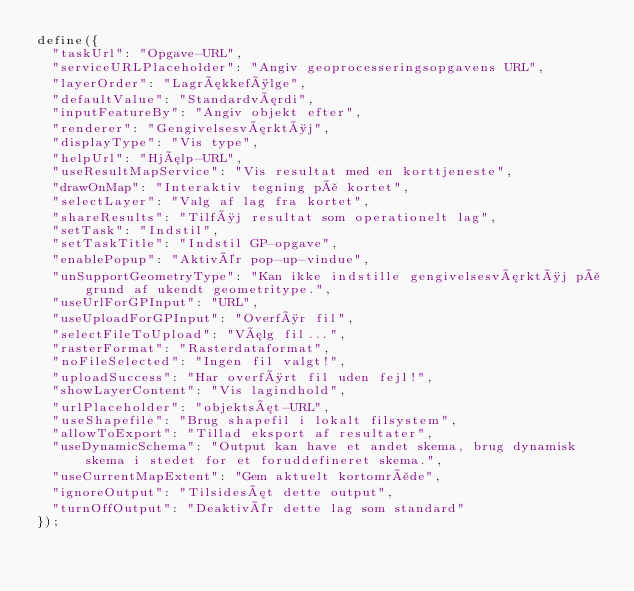<code> <loc_0><loc_0><loc_500><loc_500><_JavaScript_>define({
  "taskUrl": "Opgave-URL",
  "serviceURLPlaceholder": "Angiv geoprocesseringsopgavens URL",
  "layerOrder": "Lagrækkefølge",
  "defaultValue": "Standardværdi",
  "inputFeatureBy": "Angiv objekt efter",
  "renderer": "Gengivelsesværktøj",
  "displayType": "Vis type",
  "helpUrl": "Hjælp-URL",
  "useResultMapService": "Vis resultat med en korttjeneste",
  "drawOnMap": "Interaktiv tegning på kortet",
  "selectLayer": "Valg af lag fra kortet",
  "shareResults": "Tilføj resultat som operationelt lag",
  "setTask": "Indstil",
  "setTaskTitle": "Indstil GP-opgave",
  "enablePopup": "Aktivér pop-up-vindue",
  "unSupportGeometryType": "Kan ikke indstille gengivelsesværktøj på grund af ukendt geometritype.",
  "useUrlForGPInput": "URL",
  "useUploadForGPInput": "Overfør fil",
  "selectFileToUpload": "Vælg fil...",
  "rasterFormat": "Rasterdataformat",
  "noFileSelected": "Ingen fil valgt!",
  "uploadSuccess": "Har overført fil uden fejl!",
  "showLayerContent": "Vis lagindhold",
  "urlPlaceholder": "objektsæt-URL",
  "useShapefile": "Brug shapefil i lokalt filsystem",
  "allowToExport": "Tillad eksport af resultater",
  "useDynamicSchema": "Output kan have et andet skema, brug dynamisk skema i stedet for et foruddefineret skema.",
  "useCurrentMapExtent": "Gem aktuelt kortområde",
  "ignoreOutput": "Tilsidesæt dette output",
  "turnOffOutput": "Deaktivér dette lag som standard"
});</code> 